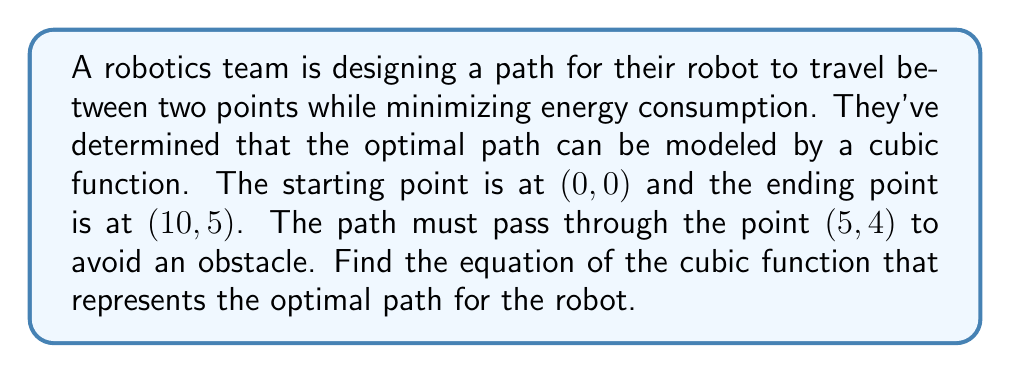Teach me how to tackle this problem. Let's approach this step-by-step:

1) The general form of a cubic function is:
   $$ f(x) = ax^3 + bx^2 + cx + d $$

2) We know three points that the function must pass through:
   (0, 0), (5, 4), and (10, 5)

3) Let's use these points to create a system of equations:

   For (0, 0): $$ 0 = d $$
   For (5, 4): $$ 4 = 125a + 25b + 5c $$
   For (10, 5): $$ 5 = 1000a + 100b + 10c $$

4) From the first equation, we know that $d = 0$. Now we have two equations with three unknowns.

5) We need one more condition. Since the path starts at (0, 0) and should smoothly transition upward, we can assume the slope at the origin is 0. This gives us:

   $$ f'(0) = c = 0 $$

6) Now our system of equations is:

   $$ 4 = 125a + 25b $$
   $$ 5 = 1000a + 100b $$
   $$ c = 0 $$

7) Subtracting 8 times the first equation from the second:
   $$ 5 - 32 = 1000a + 100b - (1000a + 200b) $$
   $$ -27 = -100b $$
   $$ b = 0.27 $$

8) Substituting this back into the first equation:
   $$ 4 = 125a + 25(0.27) $$
   $$ 4 = 125a + 6.75 $$
   $$ -2.75 = 125a $$
   $$ a = -0.022 $$

9) Therefore, the cubic function is:
   $$ f(x) = -0.022x^3 + 0.27x^2 $$
Answer: $$ f(x) = -0.022x^3 + 0.27x^2 $$ 